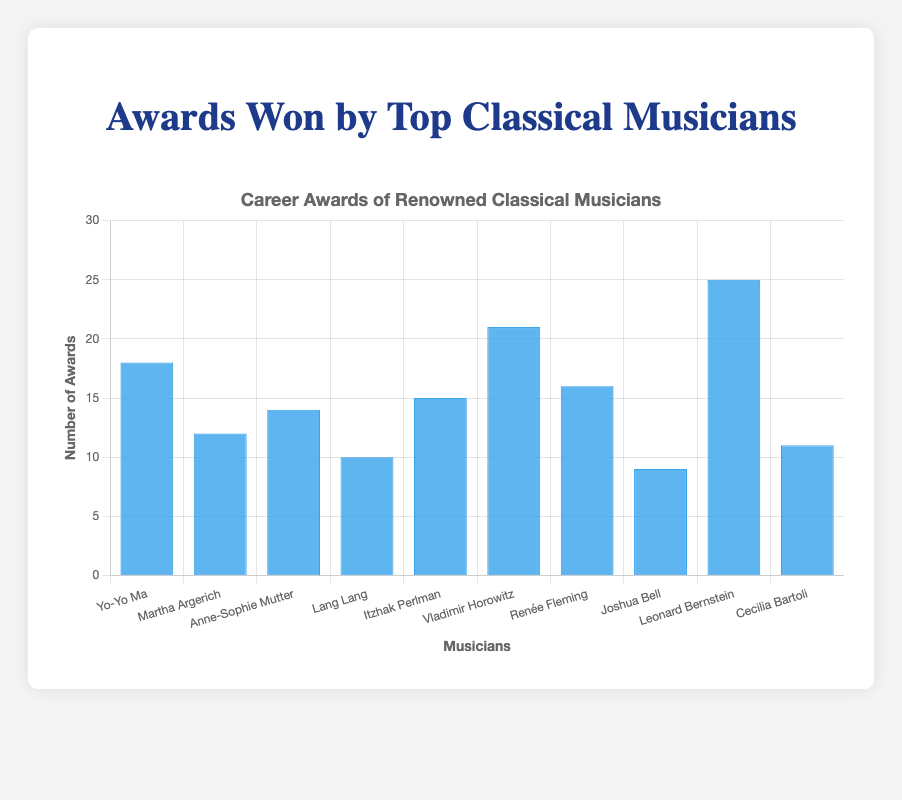Which musician has won the most awards? By looking at the chart, identify the tallest bar which corresponds to Leonard Bernstein.
Answer: Leonard Bernstein Who won more awards, Anne-Sophie Mutter or Lang Lang? Compare the height of the bars for Anne-Sophie Mutter and Lang Lang. Anne-Sophie Mutter's bar is taller than Lang Lang's bar.
Answer: Anne-Sophie Mutter What is the total number of awards won by Yo-Yo Ma, Martha Argerich, and Lang Lang? Add the awards: Yo-Yo Ma (18) + Martha Argerich (12) + Lang Lang (10) = 40.
Answer: 40 What is the average number of awards won by these musicians? Sum all the awards (18 + 12 + 14 + 10 + 15 + 21 + 16 + 9 + 25 + 11 = 151) and divide by the number of musicians (10). 151 / 10 = 15.1
Answer: 15.1 By how many awards does Renée Fleming surpass Joshua Bell? Subtract the number of awards won by Joshua Bell (9) from Renée Fleming's total (16). 16 - 9 = 7
Answer: 7 Which musicians have won more than 15 awards? Identify the bars higher than the 15 mark: Yo-Yo Ma, Vladimir Horowitz, Renée Fleming, and Leonard Bernstein.
Answer: Yo-Yo Ma, Vladimir Horowitz, Renée Fleming, and Leonard Bernstein Who has won fewer awards, Cecilia Bartoli or Joshua Bell? Compare the heights of the bars. Cecilia Bartoli's bar is higher than Joshua Bell's, indicating that Joshua Bell has won fewer awards.
Answer: Joshua Bell What's the difference between the highest and lowest number of awards won? Identify the highest (Leonard Bernstein with 25) and the lowest (Joshua Bell with 9) and subtract the two. 25 - 9 = 16
Answer: 16 How many more awards has Vladimir Horowitz won compared to Martha Argerich? Subtract Martha Argerich's total (12) from Vladimir Horowitz's total (21). 21 - 12 = 9
Answer: 9 What fraction of the total awards were won by Leonard Bernstein and Vladimir Horowitz combined? Combined awards are 25 (Bernstein) + 21 (Horowitz) = 46. Total awards are 151. The fraction is 46/151.
Answer: 46/151 